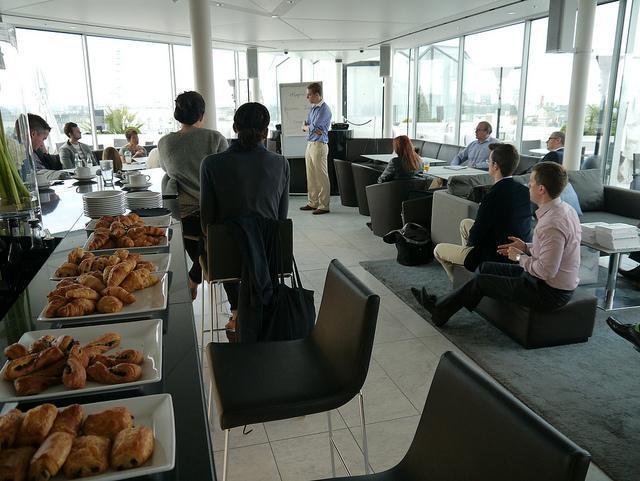How many chairs are there?
Give a very brief answer. 3. How many people can be seen?
Give a very brief answer. 5. How many couches are in the picture?
Give a very brief answer. 2. 